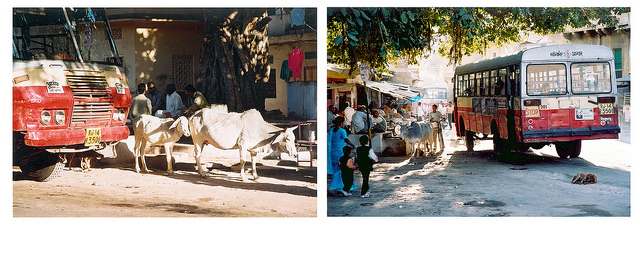Identify and read out the text in this image. STOP 